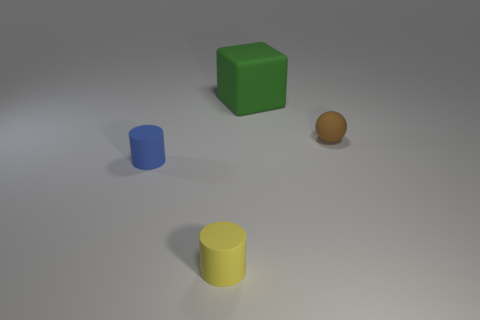Add 1 rubber spheres. How many objects exist? 5 Subtract all cubes. How many objects are left? 3 Subtract all matte cylinders. Subtract all small yellow matte cylinders. How many objects are left? 1 Add 3 big green blocks. How many big green blocks are left? 4 Add 1 tiny brown rubber cylinders. How many tiny brown rubber cylinders exist? 1 Subtract 0 gray cylinders. How many objects are left? 4 